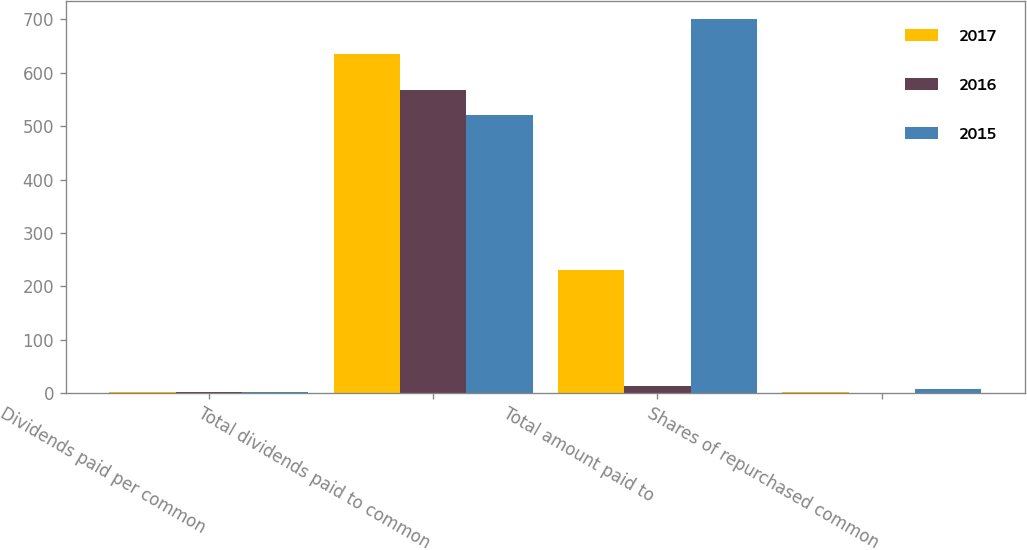Convert chart. <chart><loc_0><loc_0><loc_500><loc_500><stacked_bar_chart><ecel><fcel>Dividends paid per common<fcel>Total dividends paid to common<fcel>Total amount paid to<fcel>Shares of repurchased common<nl><fcel>2017<fcel>1.7<fcel>636<fcel>230<fcel>1.9<nl><fcel>2016<fcel>1.52<fcel>568<fcel>13<fcel>0.1<nl><fcel>2015<fcel>1.38<fcel>521<fcel>700<fcel>7.4<nl></chart> 